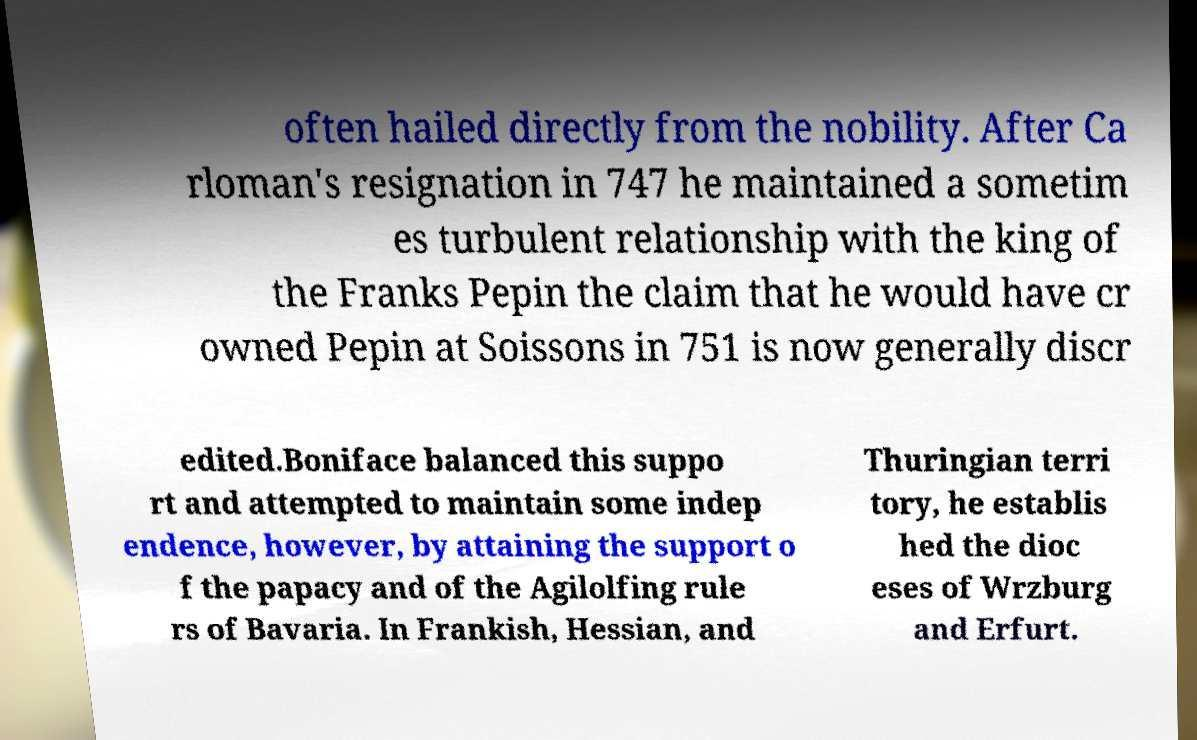What messages or text are displayed in this image? I need them in a readable, typed format. often hailed directly from the nobility. After Ca rloman's resignation in 747 he maintained a sometim es turbulent relationship with the king of the Franks Pepin the claim that he would have cr owned Pepin at Soissons in 751 is now generally discr edited.Boniface balanced this suppo rt and attempted to maintain some indep endence, however, by attaining the support o f the papacy and of the Agilolfing rule rs of Bavaria. In Frankish, Hessian, and Thuringian terri tory, he establis hed the dioc eses of Wrzburg and Erfurt. 